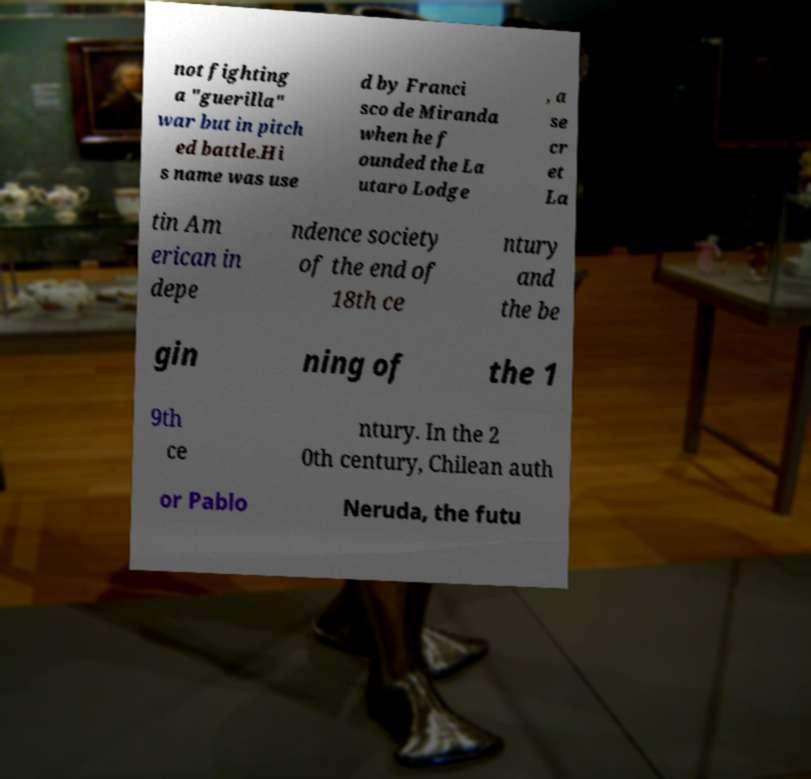Can you read and provide the text displayed in the image?This photo seems to have some interesting text. Can you extract and type it out for me? not fighting a "guerilla" war but in pitch ed battle.Hi s name was use d by Franci sco de Miranda when he f ounded the La utaro Lodge , a se cr et La tin Am erican in depe ndence society of the end of 18th ce ntury and the be gin ning of the 1 9th ce ntury. In the 2 0th century, Chilean auth or Pablo Neruda, the futu 